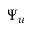Convert formula to latex. <formula><loc_0><loc_0><loc_500><loc_500>\Psi _ { u }</formula> 